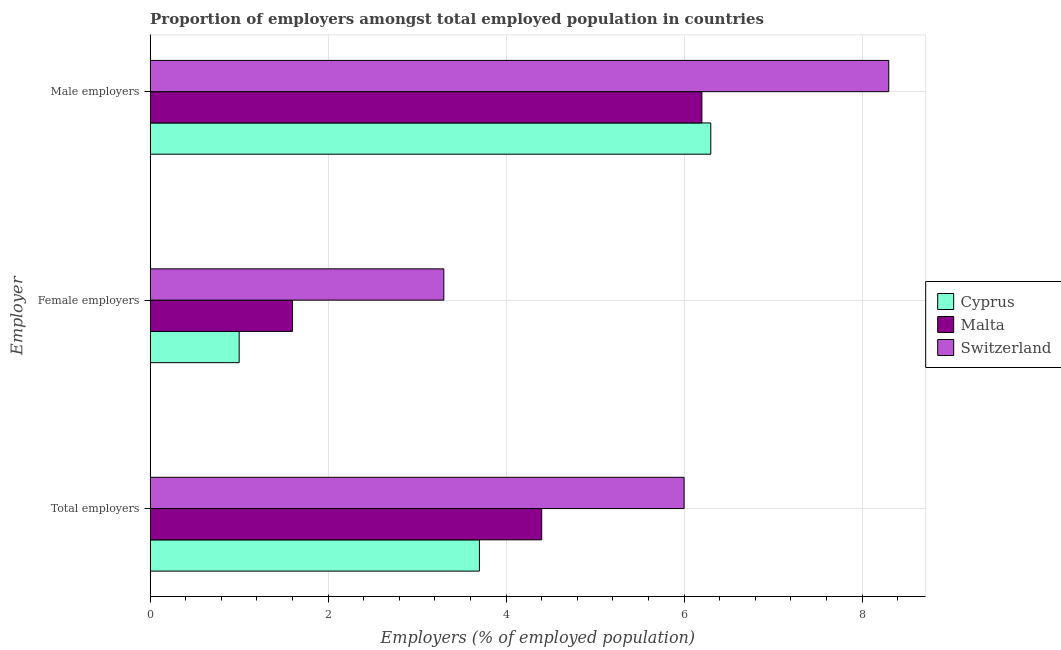How many groups of bars are there?
Give a very brief answer. 3. Are the number of bars on each tick of the Y-axis equal?
Ensure brevity in your answer.  Yes. How many bars are there on the 2nd tick from the bottom?
Your answer should be very brief. 3. What is the label of the 1st group of bars from the top?
Your answer should be very brief. Male employers. What is the percentage of male employers in Malta?
Make the answer very short. 6.2. Across all countries, what is the maximum percentage of male employers?
Your answer should be very brief. 8.3. Across all countries, what is the minimum percentage of male employers?
Offer a very short reply. 6.2. In which country was the percentage of female employers maximum?
Give a very brief answer. Switzerland. In which country was the percentage of female employers minimum?
Give a very brief answer. Cyprus. What is the total percentage of total employers in the graph?
Your answer should be very brief. 14.1. What is the difference between the percentage of male employers in Cyprus and that in Malta?
Make the answer very short. 0.1. What is the difference between the percentage of male employers in Malta and the percentage of female employers in Cyprus?
Make the answer very short. 5.2. What is the average percentage of female employers per country?
Your answer should be compact. 1.97. What is the difference between the percentage of total employers and percentage of female employers in Malta?
Your answer should be very brief. 2.8. In how many countries, is the percentage of male employers greater than 6 %?
Give a very brief answer. 3. What is the ratio of the percentage of male employers in Cyprus to that in Switzerland?
Provide a succinct answer. 0.76. Is the percentage of male employers in Cyprus less than that in Switzerland?
Provide a short and direct response. Yes. Is the difference between the percentage of male employers in Cyprus and Malta greater than the difference between the percentage of total employers in Cyprus and Malta?
Your response must be concise. Yes. What is the difference between the highest and the second highest percentage of female employers?
Your answer should be very brief. 1.7. What is the difference between the highest and the lowest percentage of male employers?
Offer a terse response. 2.1. Is the sum of the percentage of male employers in Switzerland and Malta greater than the maximum percentage of total employers across all countries?
Ensure brevity in your answer.  Yes. What does the 1st bar from the top in Total employers represents?
Offer a terse response. Switzerland. What does the 2nd bar from the bottom in Total employers represents?
Keep it short and to the point. Malta. Is it the case that in every country, the sum of the percentage of total employers and percentage of female employers is greater than the percentage of male employers?
Make the answer very short. No. How many bars are there?
Provide a succinct answer. 9. Are the values on the major ticks of X-axis written in scientific E-notation?
Give a very brief answer. No. Does the graph contain any zero values?
Offer a very short reply. No. Does the graph contain grids?
Provide a short and direct response. Yes. How are the legend labels stacked?
Your response must be concise. Vertical. What is the title of the graph?
Keep it short and to the point. Proportion of employers amongst total employed population in countries. Does "Bangladesh" appear as one of the legend labels in the graph?
Your answer should be very brief. No. What is the label or title of the X-axis?
Offer a very short reply. Employers (% of employed population). What is the label or title of the Y-axis?
Your answer should be compact. Employer. What is the Employers (% of employed population) of Cyprus in Total employers?
Offer a terse response. 3.7. What is the Employers (% of employed population) in Malta in Total employers?
Your response must be concise. 4.4. What is the Employers (% of employed population) in Switzerland in Total employers?
Provide a succinct answer. 6. What is the Employers (% of employed population) in Malta in Female employers?
Provide a short and direct response. 1.6. What is the Employers (% of employed population) of Switzerland in Female employers?
Offer a terse response. 3.3. What is the Employers (% of employed population) of Cyprus in Male employers?
Keep it short and to the point. 6.3. What is the Employers (% of employed population) of Malta in Male employers?
Your answer should be compact. 6.2. What is the Employers (% of employed population) of Switzerland in Male employers?
Your answer should be compact. 8.3. Across all Employer, what is the maximum Employers (% of employed population) of Cyprus?
Ensure brevity in your answer.  6.3. Across all Employer, what is the maximum Employers (% of employed population) in Malta?
Your answer should be very brief. 6.2. Across all Employer, what is the maximum Employers (% of employed population) of Switzerland?
Your answer should be compact. 8.3. Across all Employer, what is the minimum Employers (% of employed population) of Cyprus?
Make the answer very short. 1. Across all Employer, what is the minimum Employers (% of employed population) of Malta?
Your answer should be very brief. 1.6. Across all Employer, what is the minimum Employers (% of employed population) in Switzerland?
Keep it short and to the point. 3.3. What is the total Employers (% of employed population) in Cyprus in the graph?
Provide a succinct answer. 11. What is the difference between the Employers (% of employed population) of Switzerland in Total employers and that in Male employers?
Your response must be concise. -2.3. What is the difference between the Employers (% of employed population) in Cyprus in Female employers and that in Male employers?
Give a very brief answer. -5.3. What is the difference between the Employers (% of employed population) of Switzerland in Female employers and that in Male employers?
Your answer should be compact. -5. What is the difference between the Employers (% of employed population) in Cyprus in Total employers and the Employers (% of employed population) in Malta in Female employers?
Provide a short and direct response. 2.1. What is the difference between the Employers (% of employed population) of Cyprus in Total employers and the Employers (% of employed population) of Switzerland in Female employers?
Ensure brevity in your answer.  0.4. What is the difference between the Employers (% of employed population) in Malta in Total employers and the Employers (% of employed population) in Switzerland in Female employers?
Ensure brevity in your answer.  1.1. What is the difference between the Employers (% of employed population) in Cyprus in Total employers and the Employers (% of employed population) in Malta in Male employers?
Ensure brevity in your answer.  -2.5. What is the difference between the Employers (% of employed population) of Malta in Total employers and the Employers (% of employed population) of Switzerland in Male employers?
Your answer should be very brief. -3.9. What is the difference between the Employers (% of employed population) in Cyprus in Female employers and the Employers (% of employed population) in Malta in Male employers?
Your answer should be very brief. -5.2. What is the difference between the Employers (% of employed population) in Cyprus in Female employers and the Employers (% of employed population) in Switzerland in Male employers?
Provide a short and direct response. -7.3. What is the difference between the Employers (% of employed population) of Malta in Female employers and the Employers (% of employed population) of Switzerland in Male employers?
Offer a terse response. -6.7. What is the average Employers (% of employed population) of Cyprus per Employer?
Your answer should be compact. 3.67. What is the average Employers (% of employed population) in Malta per Employer?
Offer a very short reply. 4.07. What is the average Employers (% of employed population) of Switzerland per Employer?
Your answer should be compact. 5.87. What is the difference between the Employers (% of employed population) in Malta and Employers (% of employed population) in Switzerland in Total employers?
Offer a very short reply. -1.6. What is the difference between the Employers (% of employed population) in Cyprus and Employers (% of employed population) in Malta in Female employers?
Ensure brevity in your answer.  -0.6. What is the difference between the Employers (% of employed population) of Malta and Employers (% of employed population) of Switzerland in Female employers?
Provide a short and direct response. -1.7. What is the ratio of the Employers (% of employed population) in Malta in Total employers to that in Female employers?
Keep it short and to the point. 2.75. What is the ratio of the Employers (% of employed population) of Switzerland in Total employers to that in Female employers?
Make the answer very short. 1.82. What is the ratio of the Employers (% of employed population) of Cyprus in Total employers to that in Male employers?
Offer a terse response. 0.59. What is the ratio of the Employers (% of employed population) in Malta in Total employers to that in Male employers?
Your response must be concise. 0.71. What is the ratio of the Employers (% of employed population) in Switzerland in Total employers to that in Male employers?
Make the answer very short. 0.72. What is the ratio of the Employers (% of employed population) of Cyprus in Female employers to that in Male employers?
Your answer should be compact. 0.16. What is the ratio of the Employers (% of employed population) of Malta in Female employers to that in Male employers?
Make the answer very short. 0.26. What is the ratio of the Employers (% of employed population) in Switzerland in Female employers to that in Male employers?
Your answer should be very brief. 0.4. What is the difference between the highest and the second highest Employers (% of employed population) in Malta?
Your answer should be very brief. 1.8. 